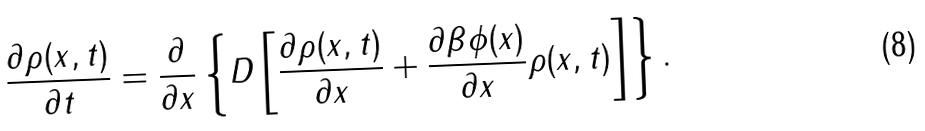<formula> <loc_0><loc_0><loc_500><loc_500>\frac { \partial \rho ( x , t ) } { \partial t } = \frac { \partial } { \partial x } \left \{ D \left [ \frac { \partial \rho ( x , t ) } { \partial x } + \frac { \partial \beta \phi ( x ) } { \partial x } \rho ( x , t ) \right ] \right \} .</formula> 